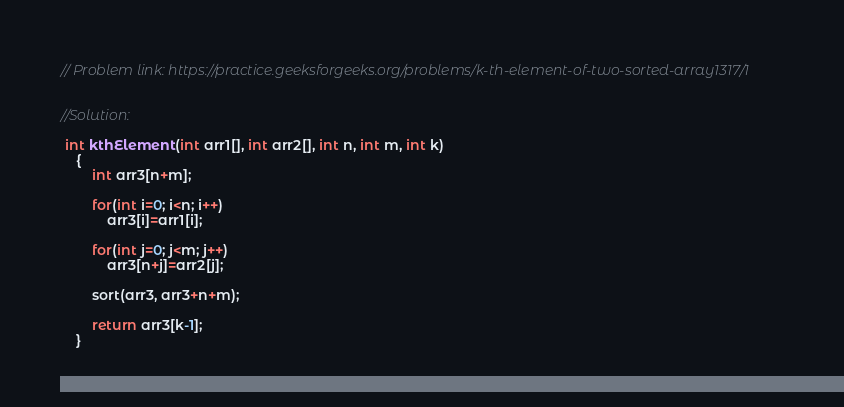Convert code to text. <code><loc_0><loc_0><loc_500><loc_500><_C++_>// Problem link: https://practice.geeksforgeeks.org/problems/k-th-element-of-two-sorted-array1317/1


//Solution:

 int kthElement(int arr1[], int arr2[], int n, int m, int k)
    {
        int arr3[n+m];

        for(int i=0; i<n; i++)
            arr3[i]=arr1[i];
            
        for(int j=0; j<m; j++)
            arr3[n+j]=arr2[j];
            
        sort(arr3, arr3+n+m);
        
        return arr3[k-1];
    }
</code> 